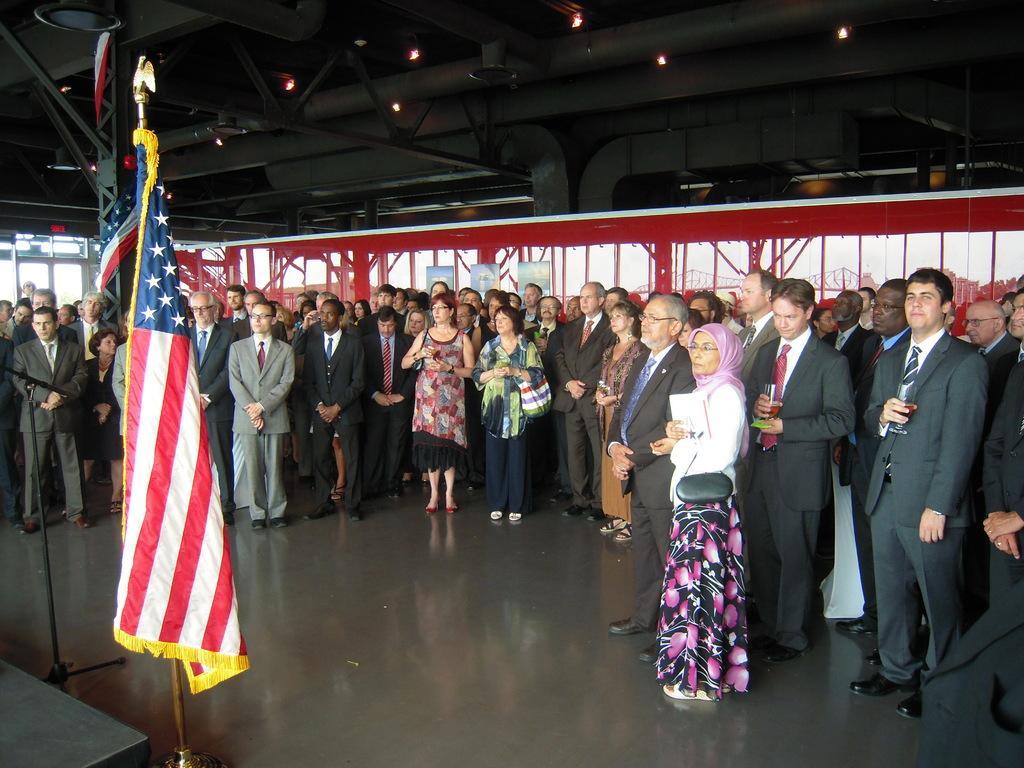Describe this image in one or two sentences. In this picture there is a group of men and women standing in the hall. In the front we can see a american flag. Behind there is a red color iron frame with glass. On the the top ceiling there are some lights. 